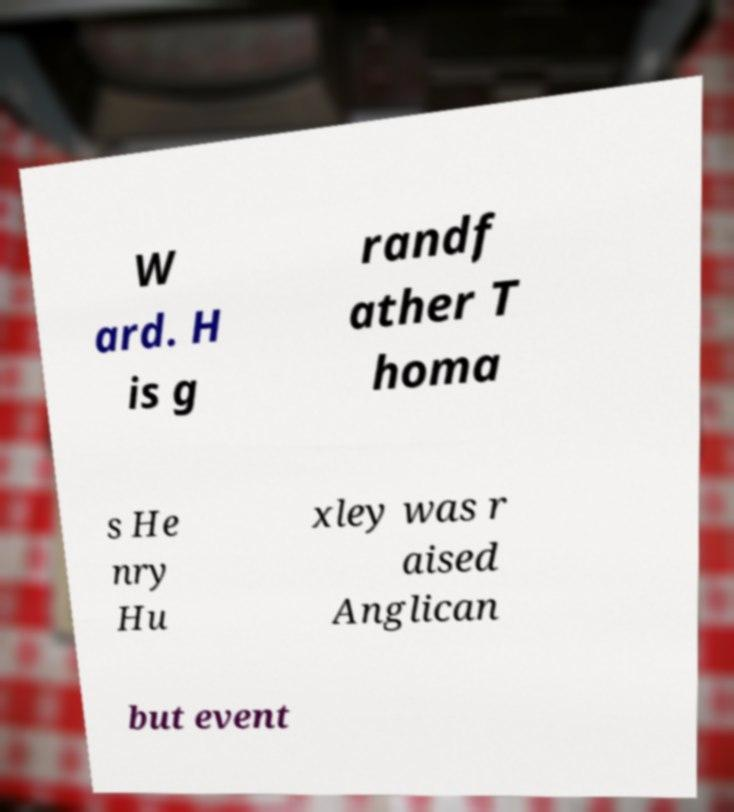Could you assist in decoding the text presented in this image and type it out clearly? W ard. H is g randf ather T homa s He nry Hu xley was r aised Anglican but event 